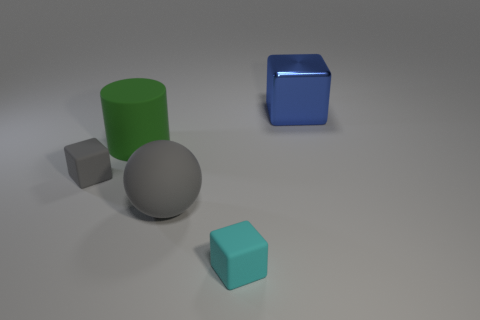Are the gray cube and the tiny object that is right of the gray matte sphere made of the same material?
Give a very brief answer. Yes. Are there any tiny cubes in front of the cube that is behind the green rubber object to the left of the large gray rubber ball?
Keep it short and to the point. Yes. Is there any other thing that has the same size as the rubber ball?
Ensure brevity in your answer.  Yes. There is a big object that is made of the same material as the large sphere; what is its color?
Offer a very short reply. Green. There is a cube that is in front of the blue metallic object and behind the small cyan matte object; what size is it?
Ensure brevity in your answer.  Small. Is the number of big matte cylinders that are right of the large green matte object less than the number of small gray blocks that are left of the gray block?
Your answer should be compact. No. Do the big thing that is in front of the big green rubber cylinder and the big block to the right of the big gray rubber ball have the same material?
Give a very brief answer. No. What shape is the thing that is both behind the cyan block and to the right of the big rubber sphere?
Make the answer very short. Cube. What is the tiny object to the right of the small block that is behind the cyan cube made of?
Provide a succinct answer. Rubber. Are there more cyan matte things than purple matte cubes?
Your response must be concise. Yes. 